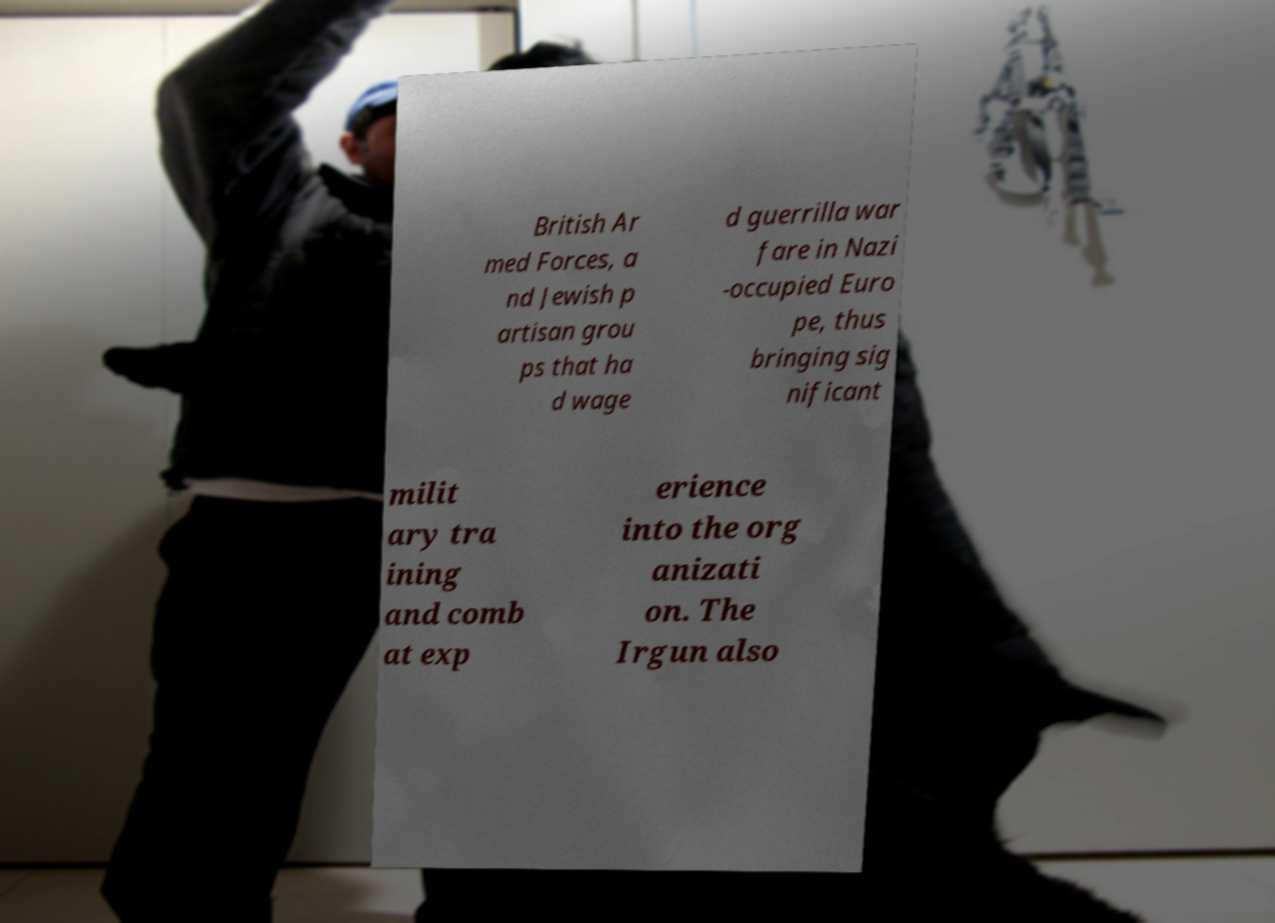What messages or text are displayed in this image? I need them in a readable, typed format. British Ar med Forces, a nd Jewish p artisan grou ps that ha d wage d guerrilla war fare in Nazi -occupied Euro pe, thus bringing sig nificant milit ary tra ining and comb at exp erience into the org anizati on. The Irgun also 